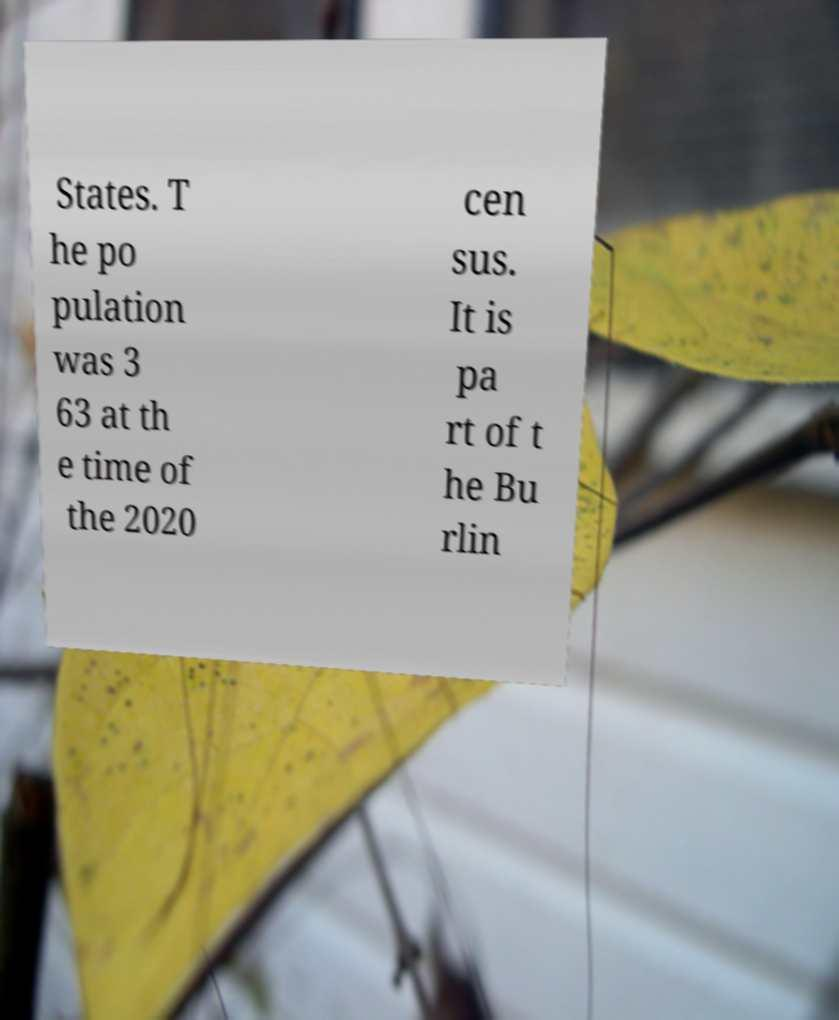Please read and relay the text visible in this image. What does it say? States. T he po pulation was 3 63 at th e time of the 2020 cen sus. It is pa rt of t he Bu rlin 